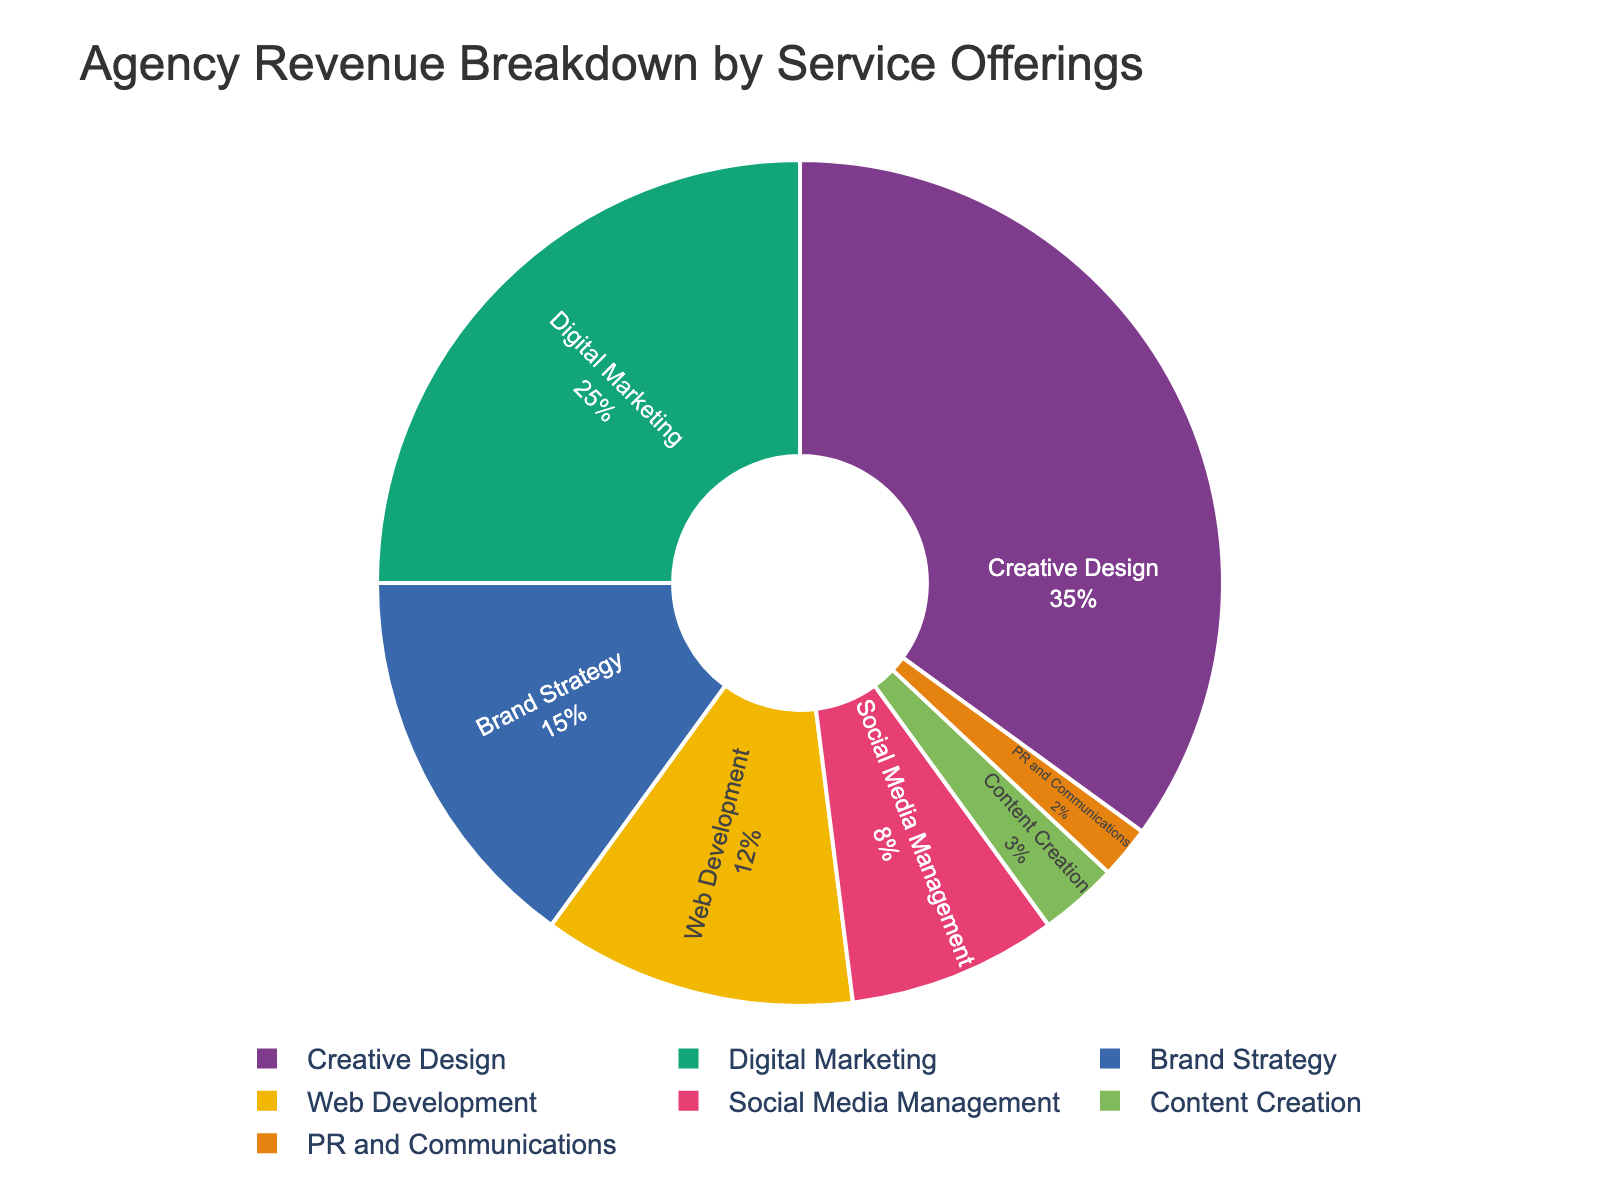what percentage of total revenue is generated by Creative Design and Web Development combined? Sum the revenue percentages of Creative Design (35%) and Web Development (12%). 35% + 12% = 47%
Answer: 47% Which service generates more revenue, Brand Strategy or Social Media Management? Compare the revenue percentages: Brand Strategy (15%) and Social Media Management (8%). Brand Strategy has a higher percentage.
Answer: Brand Strategy By what percentage does Digital Marketing exceed Content Creation in revenue? Subtract the revenue percentage of Content Creation (3%) from Digital Marketing (25%). 25% - 3% = 22%
Answer: 22% What is the smallest revenue percentage in the data, and which service does it correspond to? Identify the smallest percentage in the list: PR and Communications (2%).
Answer: PR and Communications How much more revenue does Creative Design generate compared to the combined total of PR and Communications and Social Media Management? Sum the percentages of PR and Communications (2%) and Social Media Management (8%) to get 10%. Then subtract this from Creative Design (35%). 35% - 10% = 25%
Answer: 25% Which services contribute less than 5% each to total revenue? Identify services with less than 5%: Content Creation (3%) and PR and Communications (2%).
Answer: Content Creation, PR and Communications What is the combined revenue percentage for the top two services? Sum the revenue percentages of Creative Design (35%) and Digital Marketing (25%). 35% + 25% = 60%
Answer: 60% Is the revenue generated by Web Development greater than that of Social Media Management? Compare the revenue percentages of Web Development (12%) and Social Media Management (8%). Web Development is greater.
Answer: Yes Which service offering generates less than half the revenue percentage of Brand Strategy, and what is that percentage? Half of Brand Strategy's revenue percentage is 15% / 2 = 7.5%. Content Creation (3%) and PR and Communications (2%) both generate less than this.
Answer: Content Creation, PR and Communications 